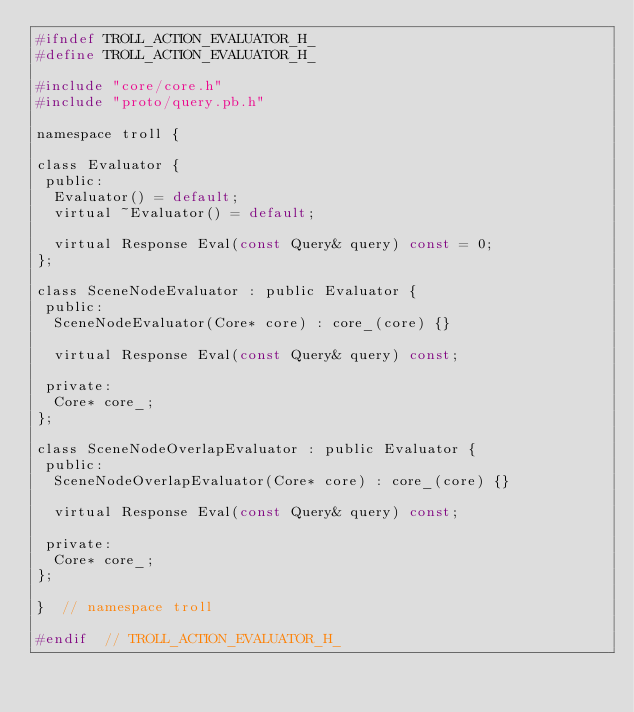<code> <loc_0><loc_0><loc_500><loc_500><_C_>#ifndef TROLL_ACTION_EVALUATOR_H_
#define TROLL_ACTION_EVALUATOR_H_

#include "core/core.h"
#include "proto/query.pb.h"

namespace troll {

class Evaluator {
 public:
  Evaluator() = default;
  virtual ~Evaluator() = default;

  virtual Response Eval(const Query& query) const = 0;
};

class SceneNodeEvaluator : public Evaluator {
 public:
  SceneNodeEvaluator(Core* core) : core_(core) {}

  virtual Response Eval(const Query& query) const;

 private:
  Core* core_;
};

class SceneNodeOverlapEvaluator : public Evaluator {
 public:
  SceneNodeOverlapEvaluator(Core* core) : core_(core) {}

  virtual Response Eval(const Query& query) const;

 private:
  Core* core_;
};

}  // namespace troll

#endif  // TROLL_ACTION_EVALUATOR_H_
</code> 